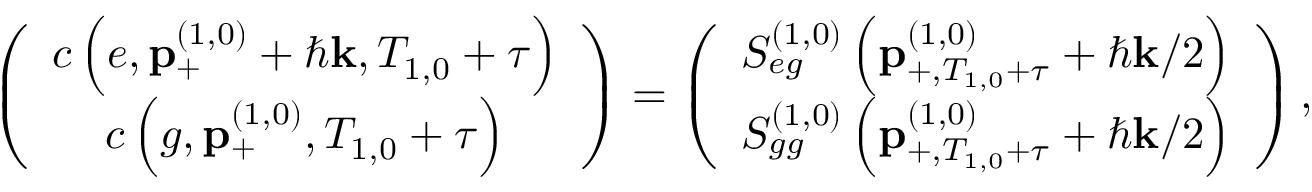<formula> <loc_0><loc_0><loc_500><loc_500>\left ( \begin{array} { c } { c \left ( e , p _ { + } ^ { \left ( 1 , 0 \right ) } + \hbar { k } , T _ { 1 , 0 } + \tau \right ) } \\ { c \left ( g , p _ { + } ^ { \left ( 1 , 0 \right ) } , T _ { 1 , 0 } + \tau \right ) } \end{array} \right ) = \left ( \begin{array} { c } { S _ { e g } ^ { \left ( 1 , 0 \right ) } \left ( p _ { + , T _ { 1 , 0 } + \tau } ^ { \left ( 1 , 0 \right ) } + \hbar { k } / 2 \right ) } \\ { S _ { g g } ^ { \left ( 1 , 0 \right ) } \left ( p _ { + , T _ { 1 , 0 } + \tau } ^ { \left ( 1 , 0 \right ) } + \hbar { k } / 2 \right ) } \end{array} \right ) ,</formula> 